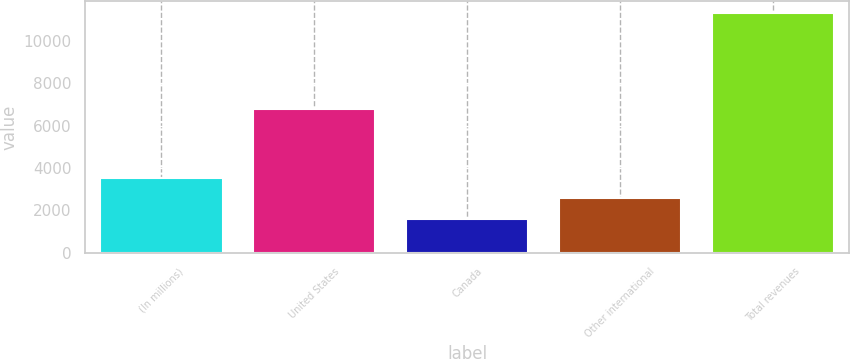Convert chart to OTSL. <chart><loc_0><loc_0><loc_500><loc_500><bar_chart><fcel>(In millions)<fcel>United States<fcel>Canada<fcel>Other international<fcel>Total revenues<nl><fcel>3540.2<fcel>6813<fcel>1594<fcel>2567.1<fcel>11325<nl></chart> 